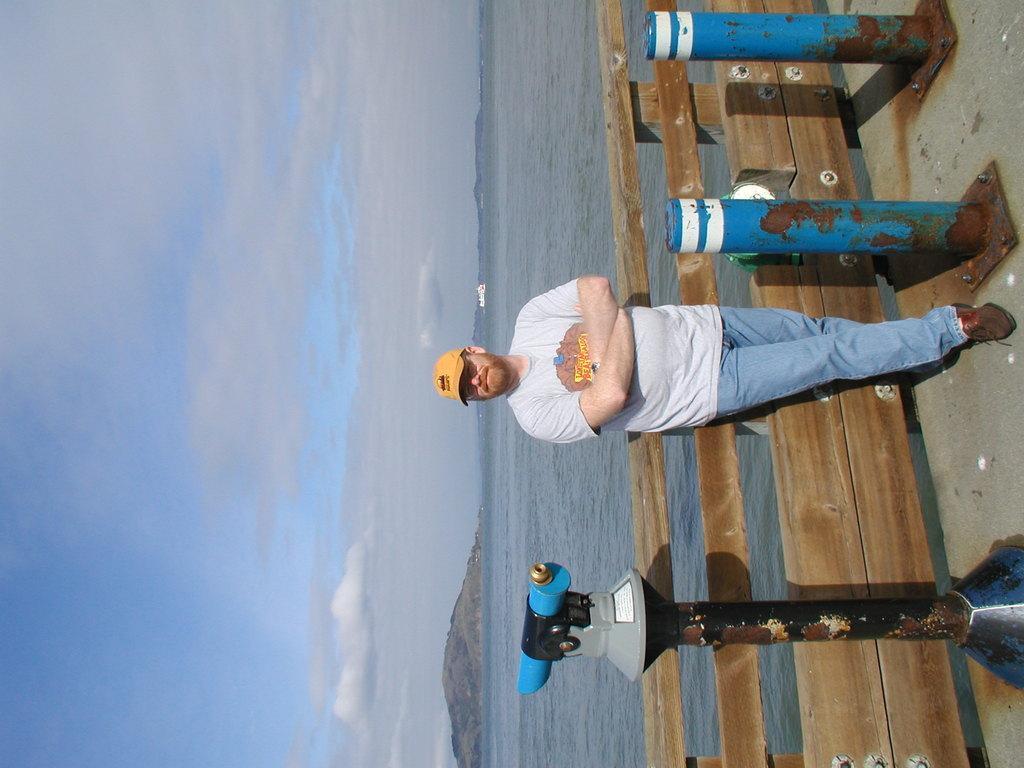Can you describe this image briefly? In this picture we can see a person standing on the ground, he is wearing a cap, at the back of him we can see a fence, here we can see an object and metal poles and in the background we can see an object, water, mountains and sky. 